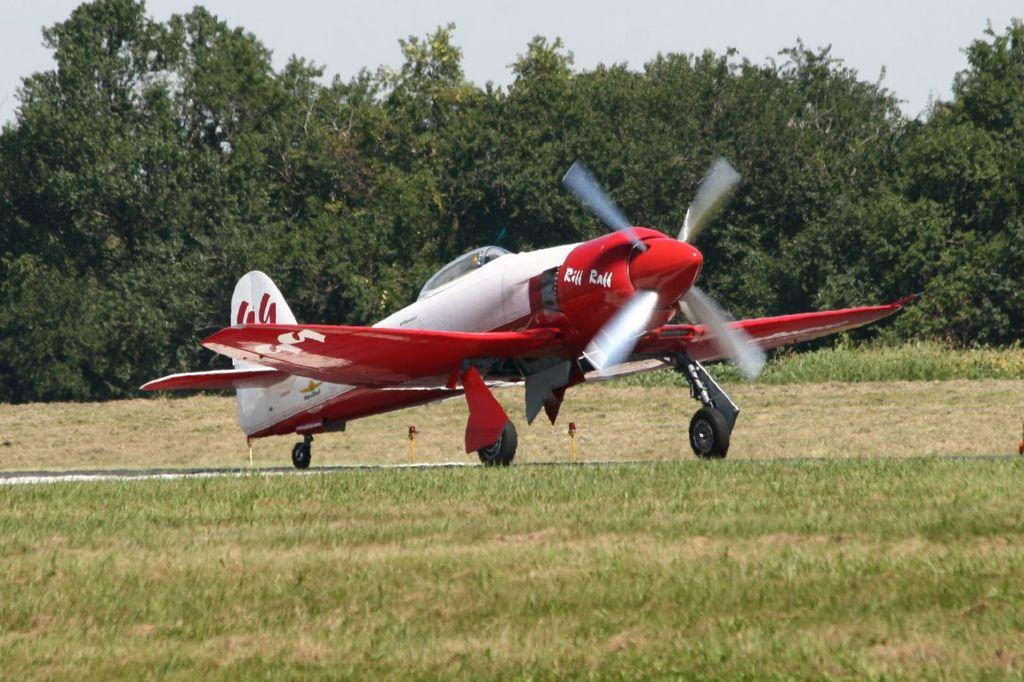What is the main subject in the center of the image? There is a helicopter in the center of the image. What type of terrain is visible at the bottom of the image? There is grass at the bottom of the image. What can be seen in the background of the image? There are trees and the sky visible in the background of the image. What emotion is the helicopter expressing in the image? Helicopters do not express emotions, as they are inanimate objects. 